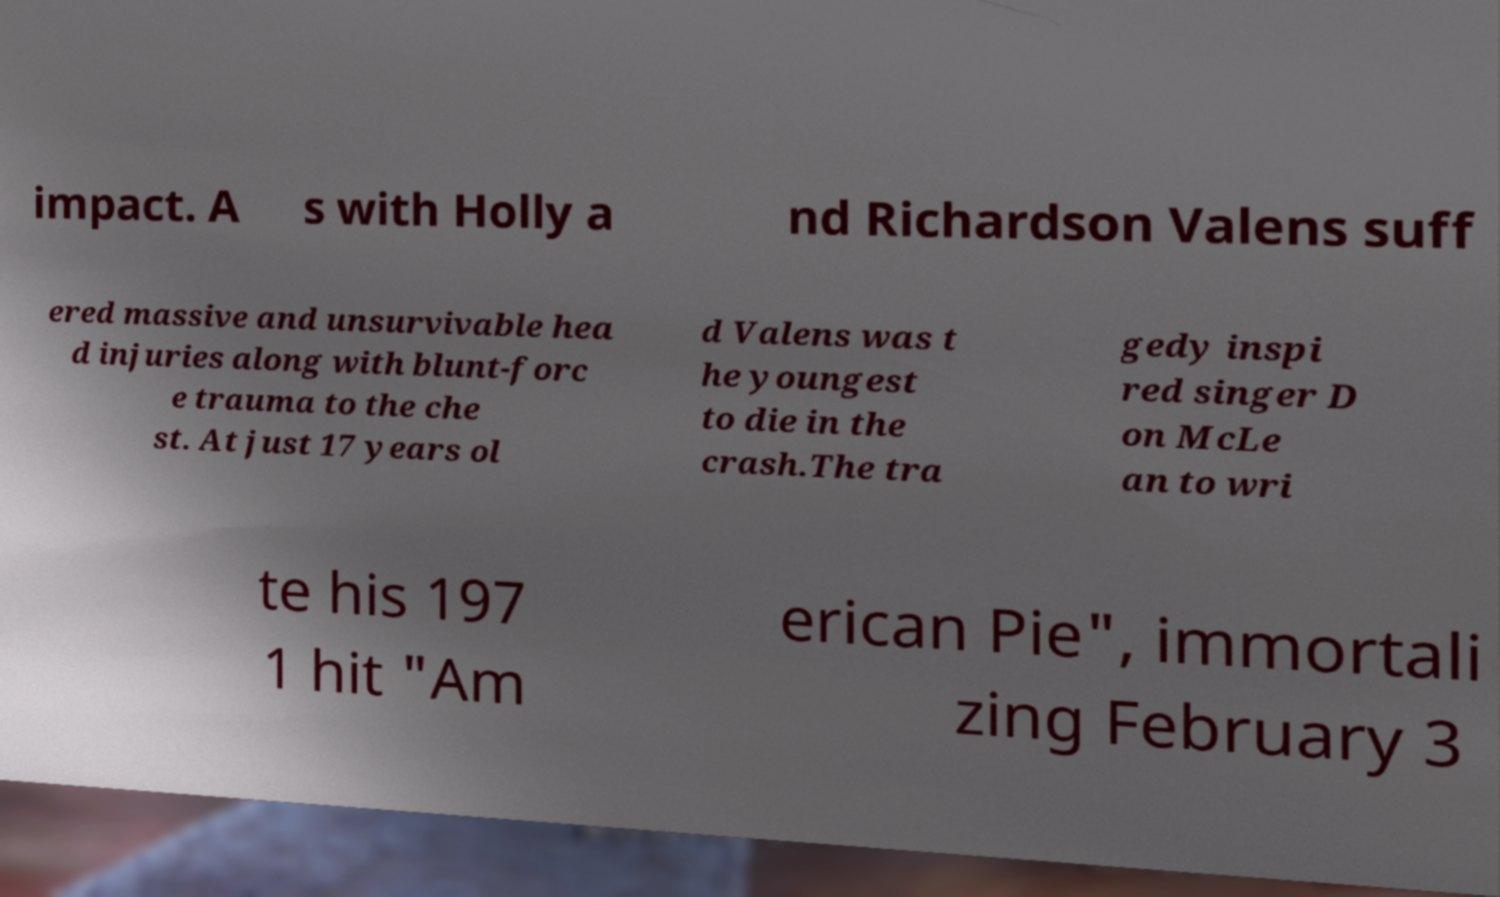There's text embedded in this image that I need extracted. Can you transcribe it verbatim? impact. A s with Holly a nd Richardson Valens suff ered massive and unsurvivable hea d injuries along with blunt-forc e trauma to the che st. At just 17 years ol d Valens was t he youngest to die in the crash.The tra gedy inspi red singer D on McLe an to wri te his 197 1 hit "Am erican Pie", immortali zing February 3 